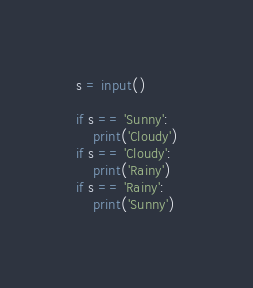Convert code to text. <code><loc_0><loc_0><loc_500><loc_500><_Python_>s = input()

if s == 'Sunny':
    print('Cloudy')
if s == 'Cloudy':
    print('Rainy')
if s == 'Rainy':
    print('Sunny')</code> 